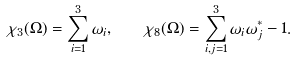Convert formula to latex. <formula><loc_0><loc_0><loc_500><loc_500>\chi _ { 3 } ( \Omega ) = \sum _ { i = 1 } ^ { 3 } \omega _ { i } , \quad \chi _ { 8 } ( \Omega ) = \sum _ { i , j = 1 } ^ { 3 } \omega _ { i } \omega _ { j } ^ { * } - 1 .</formula> 